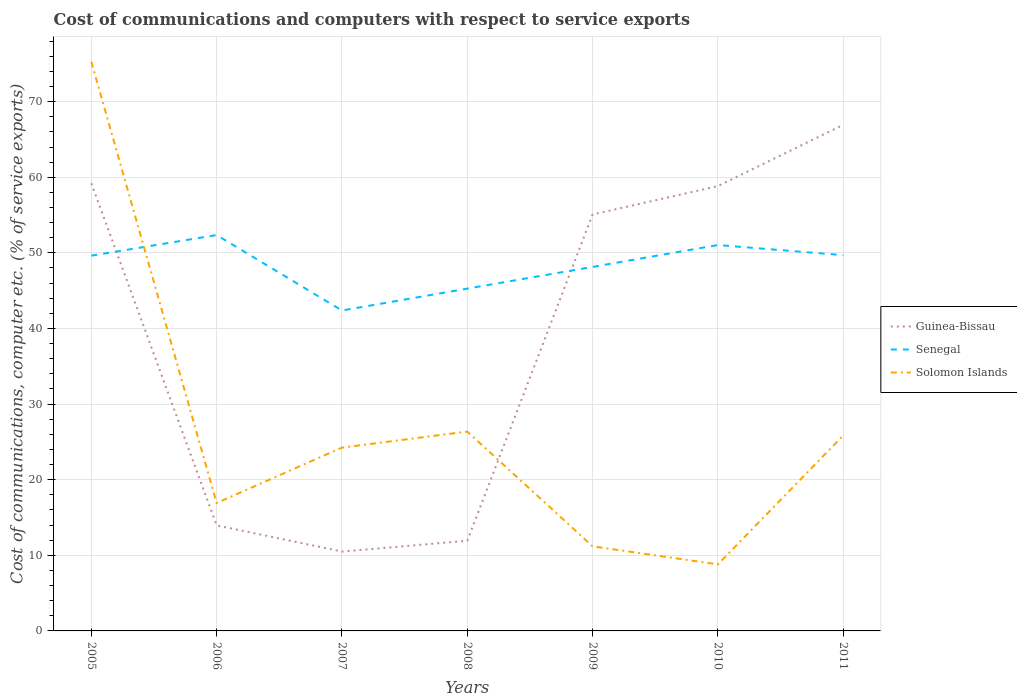How many different coloured lines are there?
Make the answer very short. 3. Does the line corresponding to Solomon Islands intersect with the line corresponding to Guinea-Bissau?
Provide a succinct answer. Yes. Across all years, what is the maximum cost of communications and computers in Guinea-Bissau?
Offer a terse response. 10.49. In which year was the cost of communications and computers in Solomon Islands maximum?
Give a very brief answer. 2010. What is the total cost of communications and computers in Solomon Islands in the graph?
Provide a succinct answer. 64.09. What is the difference between the highest and the second highest cost of communications and computers in Guinea-Bissau?
Give a very brief answer. 56.44. Is the cost of communications and computers in Solomon Islands strictly greater than the cost of communications and computers in Senegal over the years?
Your answer should be very brief. No. How many years are there in the graph?
Provide a succinct answer. 7. Are the values on the major ticks of Y-axis written in scientific E-notation?
Your answer should be compact. No. Does the graph contain grids?
Provide a succinct answer. Yes. Where does the legend appear in the graph?
Offer a very short reply. Center right. What is the title of the graph?
Your answer should be compact. Cost of communications and computers with respect to service exports. Does "Panama" appear as one of the legend labels in the graph?
Give a very brief answer. No. What is the label or title of the X-axis?
Your response must be concise. Years. What is the label or title of the Y-axis?
Provide a succinct answer. Cost of communications, computer etc. (% of service exports). What is the Cost of communications, computer etc. (% of service exports) in Guinea-Bissau in 2005?
Your response must be concise. 59.21. What is the Cost of communications, computer etc. (% of service exports) of Senegal in 2005?
Offer a terse response. 49.63. What is the Cost of communications, computer etc. (% of service exports) of Solomon Islands in 2005?
Your answer should be very brief. 75.28. What is the Cost of communications, computer etc. (% of service exports) in Guinea-Bissau in 2006?
Make the answer very short. 13.96. What is the Cost of communications, computer etc. (% of service exports) of Senegal in 2006?
Keep it short and to the point. 52.36. What is the Cost of communications, computer etc. (% of service exports) of Solomon Islands in 2006?
Your answer should be compact. 16.92. What is the Cost of communications, computer etc. (% of service exports) of Guinea-Bissau in 2007?
Your answer should be very brief. 10.49. What is the Cost of communications, computer etc. (% of service exports) of Senegal in 2007?
Keep it short and to the point. 42.38. What is the Cost of communications, computer etc. (% of service exports) of Solomon Islands in 2007?
Make the answer very short. 24.25. What is the Cost of communications, computer etc. (% of service exports) in Guinea-Bissau in 2008?
Provide a short and direct response. 11.93. What is the Cost of communications, computer etc. (% of service exports) in Senegal in 2008?
Offer a very short reply. 45.27. What is the Cost of communications, computer etc. (% of service exports) in Solomon Islands in 2008?
Keep it short and to the point. 26.37. What is the Cost of communications, computer etc. (% of service exports) in Guinea-Bissau in 2009?
Provide a short and direct response. 55.07. What is the Cost of communications, computer etc. (% of service exports) in Senegal in 2009?
Provide a short and direct response. 48.14. What is the Cost of communications, computer etc. (% of service exports) of Solomon Islands in 2009?
Provide a succinct answer. 11.19. What is the Cost of communications, computer etc. (% of service exports) in Guinea-Bissau in 2010?
Give a very brief answer. 58.83. What is the Cost of communications, computer etc. (% of service exports) of Senegal in 2010?
Offer a very short reply. 51.04. What is the Cost of communications, computer etc. (% of service exports) in Solomon Islands in 2010?
Make the answer very short. 8.8. What is the Cost of communications, computer etc. (% of service exports) in Guinea-Bissau in 2011?
Make the answer very short. 66.94. What is the Cost of communications, computer etc. (% of service exports) of Senegal in 2011?
Provide a short and direct response. 49.7. What is the Cost of communications, computer etc. (% of service exports) in Solomon Islands in 2011?
Your answer should be very brief. 25.86. Across all years, what is the maximum Cost of communications, computer etc. (% of service exports) of Guinea-Bissau?
Provide a short and direct response. 66.94. Across all years, what is the maximum Cost of communications, computer etc. (% of service exports) in Senegal?
Make the answer very short. 52.36. Across all years, what is the maximum Cost of communications, computer etc. (% of service exports) in Solomon Islands?
Provide a short and direct response. 75.28. Across all years, what is the minimum Cost of communications, computer etc. (% of service exports) of Guinea-Bissau?
Provide a succinct answer. 10.49. Across all years, what is the minimum Cost of communications, computer etc. (% of service exports) of Senegal?
Make the answer very short. 42.38. Across all years, what is the minimum Cost of communications, computer etc. (% of service exports) in Solomon Islands?
Provide a short and direct response. 8.8. What is the total Cost of communications, computer etc. (% of service exports) of Guinea-Bissau in the graph?
Offer a terse response. 276.43. What is the total Cost of communications, computer etc. (% of service exports) of Senegal in the graph?
Keep it short and to the point. 338.51. What is the total Cost of communications, computer etc. (% of service exports) in Solomon Islands in the graph?
Offer a terse response. 188.66. What is the difference between the Cost of communications, computer etc. (% of service exports) of Guinea-Bissau in 2005 and that in 2006?
Your answer should be very brief. 45.25. What is the difference between the Cost of communications, computer etc. (% of service exports) of Senegal in 2005 and that in 2006?
Offer a very short reply. -2.73. What is the difference between the Cost of communications, computer etc. (% of service exports) in Solomon Islands in 2005 and that in 2006?
Ensure brevity in your answer.  58.36. What is the difference between the Cost of communications, computer etc. (% of service exports) in Guinea-Bissau in 2005 and that in 2007?
Your response must be concise. 48.71. What is the difference between the Cost of communications, computer etc. (% of service exports) of Senegal in 2005 and that in 2007?
Offer a very short reply. 7.25. What is the difference between the Cost of communications, computer etc. (% of service exports) in Solomon Islands in 2005 and that in 2007?
Provide a short and direct response. 51.04. What is the difference between the Cost of communications, computer etc. (% of service exports) in Guinea-Bissau in 2005 and that in 2008?
Offer a terse response. 47.28. What is the difference between the Cost of communications, computer etc. (% of service exports) of Senegal in 2005 and that in 2008?
Ensure brevity in your answer.  4.36. What is the difference between the Cost of communications, computer etc. (% of service exports) in Solomon Islands in 2005 and that in 2008?
Offer a terse response. 48.92. What is the difference between the Cost of communications, computer etc. (% of service exports) in Guinea-Bissau in 2005 and that in 2009?
Provide a succinct answer. 4.14. What is the difference between the Cost of communications, computer etc. (% of service exports) of Senegal in 2005 and that in 2009?
Offer a terse response. 1.48. What is the difference between the Cost of communications, computer etc. (% of service exports) of Solomon Islands in 2005 and that in 2009?
Your answer should be very brief. 64.09. What is the difference between the Cost of communications, computer etc. (% of service exports) of Guinea-Bissau in 2005 and that in 2010?
Make the answer very short. 0.38. What is the difference between the Cost of communications, computer etc. (% of service exports) of Senegal in 2005 and that in 2010?
Provide a succinct answer. -1.41. What is the difference between the Cost of communications, computer etc. (% of service exports) in Solomon Islands in 2005 and that in 2010?
Your answer should be very brief. 66.48. What is the difference between the Cost of communications, computer etc. (% of service exports) of Guinea-Bissau in 2005 and that in 2011?
Provide a succinct answer. -7.73. What is the difference between the Cost of communications, computer etc. (% of service exports) of Senegal in 2005 and that in 2011?
Provide a succinct answer. -0.07. What is the difference between the Cost of communications, computer etc. (% of service exports) in Solomon Islands in 2005 and that in 2011?
Give a very brief answer. 49.43. What is the difference between the Cost of communications, computer etc. (% of service exports) in Guinea-Bissau in 2006 and that in 2007?
Keep it short and to the point. 3.46. What is the difference between the Cost of communications, computer etc. (% of service exports) in Senegal in 2006 and that in 2007?
Your answer should be very brief. 9.98. What is the difference between the Cost of communications, computer etc. (% of service exports) in Solomon Islands in 2006 and that in 2007?
Offer a very short reply. -7.33. What is the difference between the Cost of communications, computer etc. (% of service exports) in Guinea-Bissau in 2006 and that in 2008?
Provide a succinct answer. 2.03. What is the difference between the Cost of communications, computer etc. (% of service exports) of Senegal in 2006 and that in 2008?
Your answer should be very brief. 7.09. What is the difference between the Cost of communications, computer etc. (% of service exports) of Solomon Islands in 2006 and that in 2008?
Give a very brief answer. -9.45. What is the difference between the Cost of communications, computer etc. (% of service exports) in Guinea-Bissau in 2006 and that in 2009?
Make the answer very short. -41.11. What is the difference between the Cost of communications, computer etc. (% of service exports) of Senegal in 2006 and that in 2009?
Provide a short and direct response. 4.21. What is the difference between the Cost of communications, computer etc. (% of service exports) in Solomon Islands in 2006 and that in 2009?
Provide a succinct answer. 5.73. What is the difference between the Cost of communications, computer etc. (% of service exports) of Guinea-Bissau in 2006 and that in 2010?
Offer a terse response. -44.87. What is the difference between the Cost of communications, computer etc. (% of service exports) of Senegal in 2006 and that in 2010?
Provide a succinct answer. 1.32. What is the difference between the Cost of communications, computer etc. (% of service exports) of Solomon Islands in 2006 and that in 2010?
Ensure brevity in your answer.  8.12. What is the difference between the Cost of communications, computer etc. (% of service exports) of Guinea-Bissau in 2006 and that in 2011?
Your answer should be very brief. -52.98. What is the difference between the Cost of communications, computer etc. (% of service exports) in Senegal in 2006 and that in 2011?
Your answer should be very brief. 2.66. What is the difference between the Cost of communications, computer etc. (% of service exports) in Solomon Islands in 2006 and that in 2011?
Keep it short and to the point. -8.94. What is the difference between the Cost of communications, computer etc. (% of service exports) in Guinea-Bissau in 2007 and that in 2008?
Offer a very short reply. -1.43. What is the difference between the Cost of communications, computer etc. (% of service exports) in Senegal in 2007 and that in 2008?
Provide a short and direct response. -2.9. What is the difference between the Cost of communications, computer etc. (% of service exports) in Solomon Islands in 2007 and that in 2008?
Your answer should be compact. -2.12. What is the difference between the Cost of communications, computer etc. (% of service exports) of Guinea-Bissau in 2007 and that in 2009?
Give a very brief answer. -44.58. What is the difference between the Cost of communications, computer etc. (% of service exports) of Senegal in 2007 and that in 2009?
Your answer should be compact. -5.77. What is the difference between the Cost of communications, computer etc. (% of service exports) in Solomon Islands in 2007 and that in 2009?
Give a very brief answer. 13.06. What is the difference between the Cost of communications, computer etc. (% of service exports) of Guinea-Bissau in 2007 and that in 2010?
Provide a succinct answer. -48.34. What is the difference between the Cost of communications, computer etc. (% of service exports) in Senegal in 2007 and that in 2010?
Your answer should be compact. -8.66. What is the difference between the Cost of communications, computer etc. (% of service exports) in Solomon Islands in 2007 and that in 2010?
Keep it short and to the point. 15.44. What is the difference between the Cost of communications, computer etc. (% of service exports) in Guinea-Bissau in 2007 and that in 2011?
Your answer should be compact. -56.44. What is the difference between the Cost of communications, computer etc. (% of service exports) in Senegal in 2007 and that in 2011?
Give a very brief answer. -7.32. What is the difference between the Cost of communications, computer etc. (% of service exports) in Solomon Islands in 2007 and that in 2011?
Provide a succinct answer. -1.61. What is the difference between the Cost of communications, computer etc. (% of service exports) in Guinea-Bissau in 2008 and that in 2009?
Make the answer very short. -43.15. What is the difference between the Cost of communications, computer etc. (% of service exports) in Senegal in 2008 and that in 2009?
Ensure brevity in your answer.  -2.87. What is the difference between the Cost of communications, computer etc. (% of service exports) of Solomon Islands in 2008 and that in 2009?
Keep it short and to the point. 15.18. What is the difference between the Cost of communications, computer etc. (% of service exports) in Guinea-Bissau in 2008 and that in 2010?
Make the answer very short. -46.91. What is the difference between the Cost of communications, computer etc. (% of service exports) in Senegal in 2008 and that in 2010?
Make the answer very short. -5.76. What is the difference between the Cost of communications, computer etc. (% of service exports) of Solomon Islands in 2008 and that in 2010?
Keep it short and to the point. 17.56. What is the difference between the Cost of communications, computer etc. (% of service exports) of Guinea-Bissau in 2008 and that in 2011?
Your answer should be very brief. -55.01. What is the difference between the Cost of communications, computer etc. (% of service exports) of Senegal in 2008 and that in 2011?
Offer a terse response. -4.42. What is the difference between the Cost of communications, computer etc. (% of service exports) of Solomon Islands in 2008 and that in 2011?
Your answer should be compact. 0.51. What is the difference between the Cost of communications, computer etc. (% of service exports) in Guinea-Bissau in 2009 and that in 2010?
Provide a short and direct response. -3.76. What is the difference between the Cost of communications, computer etc. (% of service exports) of Senegal in 2009 and that in 2010?
Your answer should be very brief. -2.89. What is the difference between the Cost of communications, computer etc. (% of service exports) of Solomon Islands in 2009 and that in 2010?
Offer a very short reply. 2.39. What is the difference between the Cost of communications, computer etc. (% of service exports) of Guinea-Bissau in 2009 and that in 2011?
Provide a succinct answer. -11.86. What is the difference between the Cost of communications, computer etc. (% of service exports) in Senegal in 2009 and that in 2011?
Your answer should be compact. -1.55. What is the difference between the Cost of communications, computer etc. (% of service exports) in Solomon Islands in 2009 and that in 2011?
Make the answer very short. -14.67. What is the difference between the Cost of communications, computer etc. (% of service exports) of Guinea-Bissau in 2010 and that in 2011?
Offer a terse response. -8.1. What is the difference between the Cost of communications, computer etc. (% of service exports) in Senegal in 2010 and that in 2011?
Offer a terse response. 1.34. What is the difference between the Cost of communications, computer etc. (% of service exports) of Solomon Islands in 2010 and that in 2011?
Provide a succinct answer. -17.05. What is the difference between the Cost of communications, computer etc. (% of service exports) in Guinea-Bissau in 2005 and the Cost of communications, computer etc. (% of service exports) in Senegal in 2006?
Provide a succinct answer. 6.85. What is the difference between the Cost of communications, computer etc. (% of service exports) of Guinea-Bissau in 2005 and the Cost of communications, computer etc. (% of service exports) of Solomon Islands in 2006?
Give a very brief answer. 42.29. What is the difference between the Cost of communications, computer etc. (% of service exports) in Senegal in 2005 and the Cost of communications, computer etc. (% of service exports) in Solomon Islands in 2006?
Your answer should be compact. 32.71. What is the difference between the Cost of communications, computer etc. (% of service exports) in Guinea-Bissau in 2005 and the Cost of communications, computer etc. (% of service exports) in Senegal in 2007?
Your answer should be compact. 16.83. What is the difference between the Cost of communications, computer etc. (% of service exports) in Guinea-Bissau in 2005 and the Cost of communications, computer etc. (% of service exports) in Solomon Islands in 2007?
Ensure brevity in your answer.  34.96. What is the difference between the Cost of communications, computer etc. (% of service exports) in Senegal in 2005 and the Cost of communications, computer etc. (% of service exports) in Solomon Islands in 2007?
Offer a terse response. 25.38. What is the difference between the Cost of communications, computer etc. (% of service exports) in Guinea-Bissau in 2005 and the Cost of communications, computer etc. (% of service exports) in Senegal in 2008?
Your answer should be very brief. 13.93. What is the difference between the Cost of communications, computer etc. (% of service exports) in Guinea-Bissau in 2005 and the Cost of communications, computer etc. (% of service exports) in Solomon Islands in 2008?
Your answer should be compact. 32.84. What is the difference between the Cost of communications, computer etc. (% of service exports) of Senegal in 2005 and the Cost of communications, computer etc. (% of service exports) of Solomon Islands in 2008?
Give a very brief answer. 23.26. What is the difference between the Cost of communications, computer etc. (% of service exports) of Guinea-Bissau in 2005 and the Cost of communications, computer etc. (% of service exports) of Senegal in 2009?
Your response must be concise. 11.06. What is the difference between the Cost of communications, computer etc. (% of service exports) of Guinea-Bissau in 2005 and the Cost of communications, computer etc. (% of service exports) of Solomon Islands in 2009?
Your answer should be very brief. 48.02. What is the difference between the Cost of communications, computer etc. (% of service exports) in Senegal in 2005 and the Cost of communications, computer etc. (% of service exports) in Solomon Islands in 2009?
Your response must be concise. 38.44. What is the difference between the Cost of communications, computer etc. (% of service exports) of Guinea-Bissau in 2005 and the Cost of communications, computer etc. (% of service exports) of Senegal in 2010?
Ensure brevity in your answer.  8.17. What is the difference between the Cost of communications, computer etc. (% of service exports) in Guinea-Bissau in 2005 and the Cost of communications, computer etc. (% of service exports) in Solomon Islands in 2010?
Offer a very short reply. 50.41. What is the difference between the Cost of communications, computer etc. (% of service exports) of Senegal in 2005 and the Cost of communications, computer etc. (% of service exports) of Solomon Islands in 2010?
Give a very brief answer. 40.83. What is the difference between the Cost of communications, computer etc. (% of service exports) of Guinea-Bissau in 2005 and the Cost of communications, computer etc. (% of service exports) of Senegal in 2011?
Your response must be concise. 9.51. What is the difference between the Cost of communications, computer etc. (% of service exports) of Guinea-Bissau in 2005 and the Cost of communications, computer etc. (% of service exports) of Solomon Islands in 2011?
Offer a terse response. 33.35. What is the difference between the Cost of communications, computer etc. (% of service exports) of Senegal in 2005 and the Cost of communications, computer etc. (% of service exports) of Solomon Islands in 2011?
Give a very brief answer. 23.77. What is the difference between the Cost of communications, computer etc. (% of service exports) of Guinea-Bissau in 2006 and the Cost of communications, computer etc. (% of service exports) of Senegal in 2007?
Keep it short and to the point. -28.42. What is the difference between the Cost of communications, computer etc. (% of service exports) in Guinea-Bissau in 2006 and the Cost of communications, computer etc. (% of service exports) in Solomon Islands in 2007?
Your answer should be very brief. -10.29. What is the difference between the Cost of communications, computer etc. (% of service exports) of Senegal in 2006 and the Cost of communications, computer etc. (% of service exports) of Solomon Islands in 2007?
Keep it short and to the point. 28.11. What is the difference between the Cost of communications, computer etc. (% of service exports) in Guinea-Bissau in 2006 and the Cost of communications, computer etc. (% of service exports) in Senegal in 2008?
Provide a succinct answer. -31.31. What is the difference between the Cost of communications, computer etc. (% of service exports) in Guinea-Bissau in 2006 and the Cost of communications, computer etc. (% of service exports) in Solomon Islands in 2008?
Ensure brevity in your answer.  -12.41. What is the difference between the Cost of communications, computer etc. (% of service exports) of Senegal in 2006 and the Cost of communications, computer etc. (% of service exports) of Solomon Islands in 2008?
Provide a short and direct response. 25.99. What is the difference between the Cost of communications, computer etc. (% of service exports) of Guinea-Bissau in 2006 and the Cost of communications, computer etc. (% of service exports) of Senegal in 2009?
Provide a succinct answer. -34.19. What is the difference between the Cost of communications, computer etc. (% of service exports) in Guinea-Bissau in 2006 and the Cost of communications, computer etc. (% of service exports) in Solomon Islands in 2009?
Your answer should be very brief. 2.77. What is the difference between the Cost of communications, computer etc. (% of service exports) in Senegal in 2006 and the Cost of communications, computer etc. (% of service exports) in Solomon Islands in 2009?
Provide a succinct answer. 41.17. What is the difference between the Cost of communications, computer etc. (% of service exports) in Guinea-Bissau in 2006 and the Cost of communications, computer etc. (% of service exports) in Senegal in 2010?
Provide a short and direct response. -37.08. What is the difference between the Cost of communications, computer etc. (% of service exports) in Guinea-Bissau in 2006 and the Cost of communications, computer etc. (% of service exports) in Solomon Islands in 2010?
Make the answer very short. 5.16. What is the difference between the Cost of communications, computer etc. (% of service exports) in Senegal in 2006 and the Cost of communications, computer etc. (% of service exports) in Solomon Islands in 2010?
Your answer should be very brief. 43.56. What is the difference between the Cost of communications, computer etc. (% of service exports) in Guinea-Bissau in 2006 and the Cost of communications, computer etc. (% of service exports) in Senegal in 2011?
Provide a short and direct response. -35.74. What is the difference between the Cost of communications, computer etc. (% of service exports) in Guinea-Bissau in 2006 and the Cost of communications, computer etc. (% of service exports) in Solomon Islands in 2011?
Offer a very short reply. -11.9. What is the difference between the Cost of communications, computer etc. (% of service exports) of Senegal in 2006 and the Cost of communications, computer etc. (% of service exports) of Solomon Islands in 2011?
Offer a terse response. 26.5. What is the difference between the Cost of communications, computer etc. (% of service exports) of Guinea-Bissau in 2007 and the Cost of communications, computer etc. (% of service exports) of Senegal in 2008?
Offer a very short reply. -34.78. What is the difference between the Cost of communications, computer etc. (% of service exports) in Guinea-Bissau in 2007 and the Cost of communications, computer etc. (% of service exports) in Solomon Islands in 2008?
Keep it short and to the point. -15.87. What is the difference between the Cost of communications, computer etc. (% of service exports) in Senegal in 2007 and the Cost of communications, computer etc. (% of service exports) in Solomon Islands in 2008?
Give a very brief answer. 16.01. What is the difference between the Cost of communications, computer etc. (% of service exports) in Guinea-Bissau in 2007 and the Cost of communications, computer etc. (% of service exports) in Senegal in 2009?
Offer a very short reply. -37.65. What is the difference between the Cost of communications, computer etc. (% of service exports) in Guinea-Bissau in 2007 and the Cost of communications, computer etc. (% of service exports) in Solomon Islands in 2009?
Your answer should be compact. -0.69. What is the difference between the Cost of communications, computer etc. (% of service exports) in Senegal in 2007 and the Cost of communications, computer etc. (% of service exports) in Solomon Islands in 2009?
Give a very brief answer. 31.19. What is the difference between the Cost of communications, computer etc. (% of service exports) of Guinea-Bissau in 2007 and the Cost of communications, computer etc. (% of service exports) of Senegal in 2010?
Your answer should be compact. -40.54. What is the difference between the Cost of communications, computer etc. (% of service exports) in Guinea-Bissau in 2007 and the Cost of communications, computer etc. (% of service exports) in Solomon Islands in 2010?
Your answer should be compact. 1.69. What is the difference between the Cost of communications, computer etc. (% of service exports) in Senegal in 2007 and the Cost of communications, computer etc. (% of service exports) in Solomon Islands in 2010?
Give a very brief answer. 33.57. What is the difference between the Cost of communications, computer etc. (% of service exports) of Guinea-Bissau in 2007 and the Cost of communications, computer etc. (% of service exports) of Senegal in 2011?
Your response must be concise. -39.2. What is the difference between the Cost of communications, computer etc. (% of service exports) of Guinea-Bissau in 2007 and the Cost of communications, computer etc. (% of service exports) of Solomon Islands in 2011?
Provide a succinct answer. -15.36. What is the difference between the Cost of communications, computer etc. (% of service exports) in Senegal in 2007 and the Cost of communications, computer etc. (% of service exports) in Solomon Islands in 2011?
Your response must be concise. 16.52. What is the difference between the Cost of communications, computer etc. (% of service exports) in Guinea-Bissau in 2008 and the Cost of communications, computer etc. (% of service exports) in Senegal in 2009?
Provide a short and direct response. -36.22. What is the difference between the Cost of communications, computer etc. (% of service exports) of Guinea-Bissau in 2008 and the Cost of communications, computer etc. (% of service exports) of Solomon Islands in 2009?
Ensure brevity in your answer.  0.74. What is the difference between the Cost of communications, computer etc. (% of service exports) of Senegal in 2008 and the Cost of communications, computer etc. (% of service exports) of Solomon Islands in 2009?
Your answer should be compact. 34.08. What is the difference between the Cost of communications, computer etc. (% of service exports) of Guinea-Bissau in 2008 and the Cost of communications, computer etc. (% of service exports) of Senegal in 2010?
Give a very brief answer. -39.11. What is the difference between the Cost of communications, computer etc. (% of service exports) in Guinea-Bissau in 2008 and the Cost of communications, computer etc. (% of service exports) in Solomon Islands in 2010?
Provide a short and direct response. 3.12. What is the difference between the Cost of communications, computer etc. (% of service exports) in Senegal in 2008 and the Cost of communications, computer etc. (% of service exports) in Solomon Islands in 2010?
Make the answer very short. 36.47. What is the difference between the Cost of communications, computer etc. (% of service exports) of Guinea-Bissau in 2008 and the Cost of communications, computer etc. (% of service exports) of Senegal in 2011?
Ensure brevity in your answer.  -37.77. What is the difference between the Cost of communications, computer etc. (% of service exports) in Guinea-Bissau in 2008 and the Cost of communications, computer etc. (% of service exports) in Solomon Islands in 2011?
Offer a terse response. -13.93. What is the difference between the Cost of communications, computer etc. (% of service exports) of Senegal in 2008 and the Cost of communications, computer etc. (% of service exports) of Solomon Islands in 2011?
Keep it short and to the point. 19.42. What is the difference between the Cost of communications, computer etc. (% of service exports) in Guinea-Bissau in 2009 and the Cost of communications, computer etc. (% of service exports) in Senegal in 2010?
Offer a terse response. 4.04. What is the difference between the Cost of communications, computer etc. (% of service exports) of Guinea-Bissau in 2009 and the Cost of communications, computer etc. (% of service exports) of Solomon Islands in 2010?
Ensure brevity in your answer.  46.27. What is the difference between the Cost of communications, computer etc. (% of service exports) in Senegal in 2009 and the Cost of communications, computer etc. (% of service exports) in Solomon Islands in 2010?
Provide a succinct answer. 39.34. What is the difference between the Cost of communications, computer etc. (% of service exports) of Guinea-Bissau in 2009 and the Cost of communications, computer etc. (% of service exports) of Senegal in 2011?
Make the answer very short. 5.38. What is the difference between the Cost of communications, computer etc. (% of service exports) in Guinea-Bissau in 2009 and the Cost of communications, computer etc. (% of service exports) in Solomon Islands in 2011?
Make the answer very short. 29.22. What is the difference between the Cost of communications, computer etc. (% of service exports) of Senegal in 2009 and the Cost of communications, computer etc. (% of service exports) of Solomon Islands in 2011?
Offer a very short reply. 22.29. What is the difference between the Cost of communications, computer etc. (% of service exports) in Guinea-Bissau in 2010 and the Cost of communications, computer etc. (% of service exports) in Senegal in 2011?
Ensure brevity in your answer.  9.14. What is the difference between the Cost of communications, computer etc. (% of service exports) in Guinea-Bissau in 2010 and the Cost of communications, computer etc. (% of service exports) in Solomon Islands in 2011?
Ensure brevity in your answer.  32.98. What is the difference between the Cost of communications, computer etc. (% of service exports) of Senegal in 2010 and the Cost of communications, computer etc. (% of service exports) of Solomon Islands in 2011?
Your response must be concise. 25.18. What is the average Cost of communications, computer etc. (% of service exports) of Guinea-Bissau per year?
Keep it short and to the point. 39.49. What is the average Cost of communications, computer etc. (% of service exports) of Senegal per year?
Offer a terse response. 48.36. What is the average Cost of communications, computer etc. (% of service exports) of Solomon Islands per year?
Your answer should be very brief. 26.95. In the year 2005, what is the difference between the Cost of communications, computer etc. (% of service exports) of Guinea-Bissau and Cost of communications, computer etc. (% of service exports) of Senegal?
Provide a succinct answer. 9.58. In the year 2005, what is the difference between the Cost of communications, computer etc. (% of service exports) in Guinea-Bissau and Cost of communications, computer etc. (% of service exports) in Solomon Islands?
Your response must be concise. -16.07. In the year 2005, what is the difference between the Cost of communications, computer etc. (% of service exports) in Senegal and Cost of communications, computer etc. (% of service exports) in Solomon Islands?
Your answer should be very brief. -25.65. In the year 2006, what is the difference between the Cost of communications, computer etc. (% of service exports) in Guinea-Bissau and Cost of communications, computer etc. (% of service exports) in Senegal?
Ensure brevity in your answer.  -38.4. In the year 2006, what is the difference between the Cost of communications, computer etc. (% of service exports) in Guinea-Bissau and Cost of communications, computer etc. (% of service exports) in Solomon Islands?
Your answer should be very brief. -2.96. In the year 2006, what is the difference between the Cost of communications, computer etc. (% of service exports) of Senegal and Cost of communications, computer etc. (% of service exports) of Solomon Islands?
Ensure brevity in your answer.  35.44. In the year 2007, what is the difference between the Cost of communications, computer etc. (% of service exports) in Guinea-Bissau and Cost of communications, computer etc. (% of service exports) in Senegal?
Your answer should be compact. -31.88. In the year 2007, what is the difference between the Cost of communications, computer etc. (% of service exports) in Guinea-Bissau and Cost of communications, computer etc. (% of service exports) in Solomon Islands?
Give a very brief answer. -13.75. In the year 2007, what is the difference between the Cost of communications, computer etc. (% of service exports) of Senegal and Cost of communications, computer etc. (% of service exports) of Solomon Islands?
Keep it short and to the point. 18.13. In the year 2008, what is the difference between the Cost of communications, computer etc. (% of service exports) in Guinea-Bissau and Cost of communications, computer etc. (% of service exports) in Senegal?
Provide a short and direct response. -33.35. In the year 2008, what is the difference between the Cost of communications, computer etc. (% of service exports) in Guinea-Bissau and Cost of communications, computer etc. (% of service exports) in Solomon Islands?
Offer a very short reply. -14.44. In the year 2008, what is the difference between the Cost of communications, computer etc. (% of service exports) of Senegal and Cost of communications, computer etc. (% of service exports) of Solomon Islands?
Ensure brevity in your answer.  18.91. In the year 2009, what is the difference between the Cost of communications, computer etc. (% of service exports) of Guinea-Bissau and Cost of communications, computer etc. (% of service exports) of Senegal?
Offer a terse response. 6.93. In the year 2009, what is the difference between the Cost of communications, computer etc. (% of service exports) of Guinea-Bissau and Cost of communications, computer etc. (% of service exports) of Solomon Islands?
Offer a terse response. 43.88. In the year 2009, what is the difference between the Cost of communications, computer etc. (% of service exports) of Senegal and Cost of communications, computer etc. (% of service exports) of Solomon Islands?
Your response must be concise. 36.95. In the year 2010, what is the difference between the Cost of communications, computer etc. (% of service exports) in Guinea-Bissau and Cost of communications, computer etc. (% of service exports) in Senegal?
Make the answer very short. 7.8. In the year 2010, what is the difference between the Cost of communications, computer etc. (% of service exports) of Guinea-Bissau and Cost of communications, computer etc. (% of service exports) of Solomon Islands?
Provide a short and direct response. 50.03. In the year 2010, what is the difference between the Cost of communications, computer etc. (% of service exports) of Senegal and Cost of communications, computer etc. (% of service exports) of Solomon Islands?
Give a very brief answer. 42.23. In the year 2011, what is the difference between the Cost of communications, computer etc. (% of service exports) in Guinea-Bissau and Cost of communications, computer etc. (% of service exports) in Senegal?
Your answer should be compact. 17.24. In the year 2011, what is the difference between the Cost of communications, computer etc. (% of service exports) of Guinea-Bissau and Cost of communications, computer etc. (% of service exports) of Solomon Islands?
Your answer should be very brief. 41.08. In the year 2011, what is the difference between the Cost of communications, computer etc. (% of service exports) of Senegal and Cost of communications, computer etc. (% of service exports) of Solomon Islands?
Offer a terse response. 23.84. What is the ratio of the Cost of communications, computer etc. (% of service exports) of Guinea-Bissau in 2005 to that in 2006?
Offer a terse response. 4.24. What is the ratio of the Cost of communications, computer etc. (% of service exports) of Senegal in 2005 to that in 2006?
Make the answer very short. 0.95. What is the ratio of the Cost of communications, computer etc. (% of service exports) in Solomon Islands in 2005 to that in 2006?
Provide a succinct answer. 4.45. What is the ratio of the Cost of communications, computer etc. (% of service exports) of Guinea-Bissau in 2005 to that in 2007?
Provide a succinct answer. 5.64. What is the ratio of the Cost of communications, computer etc. (% of service exports) in Senegal in 2005 to that in 2007?
Your response must be concise. 1.17. What is the ratio of the Cost of communications, computer etc. (% of service exports) of Solomon Islands in 2005 to that in 2007?
Make the answer very short. 3.1. What is the ratio of the Cost of communications, computer etc. (% of service exports) in Guinea-Bissau in 2005 to that in 2008?
Your answer should be compact. 4.96. What is the ratio of the Cost of communications, computer etc. (% of service exports) of Senegal in 2005 to that in 2008?
Offer a terse response. 1.1. What is the ratio of the Cost of communications, computer etc. (% of service exports) of Solomon Islands in 2005 to that in 2008?
Your response must be concise. 2.86. What is the ratio of the Cost of communications, computer etc. (% of service exports) in Guinea-Bissau in 2005 to that in 2009?
Your response must be concise. 1.08. What is the ratio of the Cost of communications, computer etc. (% of service exports) of Senegal in 2005 to that in 2009?
Your answer should be very brief. 1.03. What is the ratio of the Cost of communications, computer etc. (% of service exports) in Solomon Islands in 2005 to that in 2009?
Provide a short and direct response. 6.73. What is the ratio of the Cost of communications, computer etc. (% of service exports) in Guinea-Bissau in 2005 to that in 2010?
Provide a short and direct response. 1.01. What is the ratio of the Cost of communications, computer etc. (% of service exports) of Senegal in 2005 to that in 2010?
Your answer should be compact. 0.97. What is the ratio of the Cost of communications, computer etc. (% of service exports) in Solomon Islands in 2005 to that in 2010?
Provide a short and direct response. 8.55. What is the ratio of the Cost of communications, computer etc. (% of service exports) in Guinea-Bissau in 2005 to that in 2011?
Your answer should be very brief. 0.88. What is the ratio of the Cost of communications, computer etc. (% of service exports) in Senegal in 2005 to that in 2011?
Provide a succinct answer. 1. What is the ratio of the Cost of communications, computer etc. (% of service exports) of Solomon Islands in 2005 to that in 2011?
Give a very brief answer. 2.91. What is the ratio of the Cost of communications, computer etc. (% of service exports) in Guinea-Bissau in 2006 to that in 2007?
Your response must be concise. 1.33. What is the ratio of the Cost of communications, computer etc. (% of service exports) in Senegal in 2006 to that in 2007?
Provide a succinct answer. 1.24. What is the ratio of the Cost of communications, computer etc. (% of service exports) of Solomon Islands in 2006 to that in 2007?
Offer a terse response. 0.7. What is the ratio of the Cost of communications, computer etc. (% of service exports) in Guinea-Bissau in 2006 to that in 2008?
Your answer should be very brief. 1.17. What is the ratio of the Cost of communications, computer etc. (% of service exports) in Senegal in 2006 to that in 2008?
Offer a terse response. 1.16. What is the ratio of the Cost of communications, computer etc. (% of service exports) in Solomon Islands in 2006 to that in 2008?
Offer a very short reply. 0.64. What is the ratio of the Cost of communications, computer etc. (% of service exports) of Guinea-Bissau in 2006 to that in 2009?
Give a very brief answer. 0.25. What is the ratio of the Cost of communications, computer etc. (% of service exports) of Senegal in 2006 to that in 2009?
Ensure brevity in your answer.  1.09. What is the ratio of the Cost of communications, computer etc. (% of service exports) in Solomon Islands in 2006 to that in 2009?
Ensure brevity in your answer.  1.51. What is the ratio of the Cost of communications, computer etc. (% of service exports) of Guinea-Bissau in 2006 to that in 2010?
Ensure brevity in your answer.  0.24. What is the ratio of the Cost of communications, computer etc. (% of service exports) in Senegal in 2006 to that in 2010?
Make the answer very short. 1.03. What is the ratio of the Cost of communications, computer etc. (% of service exports) of Solomon Islands in 2006 to that in 2010?
Give a very brief answer. 1.92. What is the ratio of the Cost of communications, computer etc. (% of service exports) of Guinea-Bissau in 2006 to that in 2011?
Offer a very short reply. 0.21. What is the ratio of the Cost of communications, computer etc. (% of service exports) in Senegal in 2006 to that in 2011?
Give a very brief answer. 1.05. What is the ratio of the Cost of communications, computer etc. (% of service exports) in Solomon Islands in 2006 to that in 2011?
Your answer should be compact. 0.65. What is the ratio of the Cost of communications, computer etc. (% of service exports) of Guinea-Bissau in 2007 to that in 2008?
Make the answer very short. 0.88. What is the ratio of the Cost of communications, computer etc. (% of service exports) of Senegal in 2007 to that in 2008?
Your answer should be very brief. 0.94. What is the ratio of the Cost of communications, computer etc. (% of service exports) in Solomon Islands in 2007 to that in 2008?
Keep it short and to the point. 0.92. What is the ratio of the Cost of communications, computer etc. (% of service exports) of Guinea-Bissau in 2007 to that in 2009?
Provide a short and direct response. 0.19. What is the ratio of the Cost of communications, computer etc. (% of service exports) of Senegal in 2007 to that in 2009?
Make the answer very short. 0.88. What is the ratio of the Cost of communications, computer etc. (% of service exports) in Solomon Islands in 2007 to that in 2009?
Keep it short and to the point. 2.17. What is the ratio of the Cost of communications, computer etc. (% of service exports) in Guinea-Bissau in 2007 to that in 2010?
Ensure brevity in your answer.  0.18. What is the ratio of the Cost of communications, computer etc. (% of service exports) of Senegal in 2007 to that in 2010?
Offer a very short reply. 0.83. What is the ratio of the Cost of communications, computer etc. (% of service exports) of Solomon Islands in 2007 to that in 2010?
Make the answer very short. 2.75. What is the ratio of the Cost of communications, computer etc. (% of service exports) of Guinea-Bissau in 2007 to that in 2011?
Keep it short and to the point. 0.16. What is the ratio of the Cost of communications, computer etc. (% of service exports) in Senegal in 2007 to that in 2011?
Offer a terse response. 0.85. What is the ratio of the Cost of communications, computer etc. (% of service exports) in Solomon Islands in 2007 to that in 2011?
Provide a short and direct response. 0.94. What is the ratio of the Cost of communications, computer etc. (% of service exports) in Guinea-Bissau in 2008 to that in 2009?
Offer a very short reply. 0.22. What is the ratio of the Cost of communications, computer etc. (% of service exports) of Senegal in 2008 to that in 2009?
Keep it short and to the point. 0.94. What is the ratio of the Cost of communications, computer etc. (% of service exports) of Solomon Islands in 2008 to that in 2009?
Ensure brevity in your answer.  2.36. What is the ratio of the Cost of communications, computer etc. (% of service exports) in Guinea-Bissau in 2008 to that in 2010?
Your answer should be compact. 0.2. What is the ratio of the Cost of communications, computer etc. (% of service exports) of Senegal in 2008 to that in 2010?
Ensure brevity in your answer.  0.89. What is the ratio of the Cost of communications, computer etc. (% of service exports) of Solomon Islands in 2008 to that in 2010?
Offer a very short reply. 3. What is the ratio of the Cost of communications, computer etc. (% of service exports) in Guinea-Bissau in 2008 to that in 2011?
Offer a terse response. 0.18. What is the ratio of the Cost of communications, computer etc. (% of service exports) in Senegal in 2008 to that in 2011?
Make the answer very short. 0.91. What is the ratio of the Cost of communications, computer etc. (% of service exports) in Solomon Islands in 2008 to that in 2011?
Provide a succinct answer. 1.02. What is the ratio of the Cost of communications, computer etc. (% of service exports) in Guinea-Bissau in 2009 to that in 2010?
Provide a short and direct response. 0.94. What is the ratio of the Cost of communications, computer etc. (% of service exports) in Senegal in 2009 to that in 2010?
Your response must be concise. 0.94. What is the ratio of the Cost of communications, computer etc. (% of service exports) in Solomon Islands in 2009 to that in 2010?
Ensure brevity in your answer.  1.27. What is the ratio of the Cost of communications, computer etc. (% of service exports) of Guinea-Bissau in 2009 to that in 2011?
Give a very brief answer. 0.82. What is the ratio of the Cost of communications, computer etc. (% of service exports) in Senegal in 2009 to that in 2011?
Offer a terse response. 0.97. What is the ratio of the Cost of communications, computer etc. (% of service exports) in Solomon Islands in 2009 to that in 2011?
Keep it short and to the point. 0.43. What is the ratio of the Cost of communications, computer etc. (% of service exports) of Guinea-Bissau in 2010 to that in 2011?
Provide a succinct answer. 0.88. What is the ratio of the Cost of communications, computer etc. (% of service exports) in Solomon Islands in 2010 to that in 2011?
Provide a short and direct response. 0.34. What is the difference between the highest and the second highest Cost of communications, computer etc. (% of service exports) of Guinea-Bissau?
Your answer should be compact. 7.73. What is the difference between the highest and the second highest Cost of communications, computer etc. (% of service exports) in Senegal?
Provide a succinct answer. 1.32. What is the difference between the highest and the second highest Cost of communications, computer etc. (% of service exports) in Solomon Islands?
Provide a succinct answer. 48.92. What is the difference between the highest and the lowest Cost of communications, computer etc. (% of service exports) in Guinea-Bissau?
Keep it short and to the point. 56.44. What is the difference between the highest and the lowest Cost of communications, computer etc. (% of service exports) in Senegal?
Provide a succinct answer. 9.98. What is the difference between the highest and the lowest Cost of communications, computer etc. (% of service exports) in Solomon Islands?
Your answer should be compact. 66.48. 